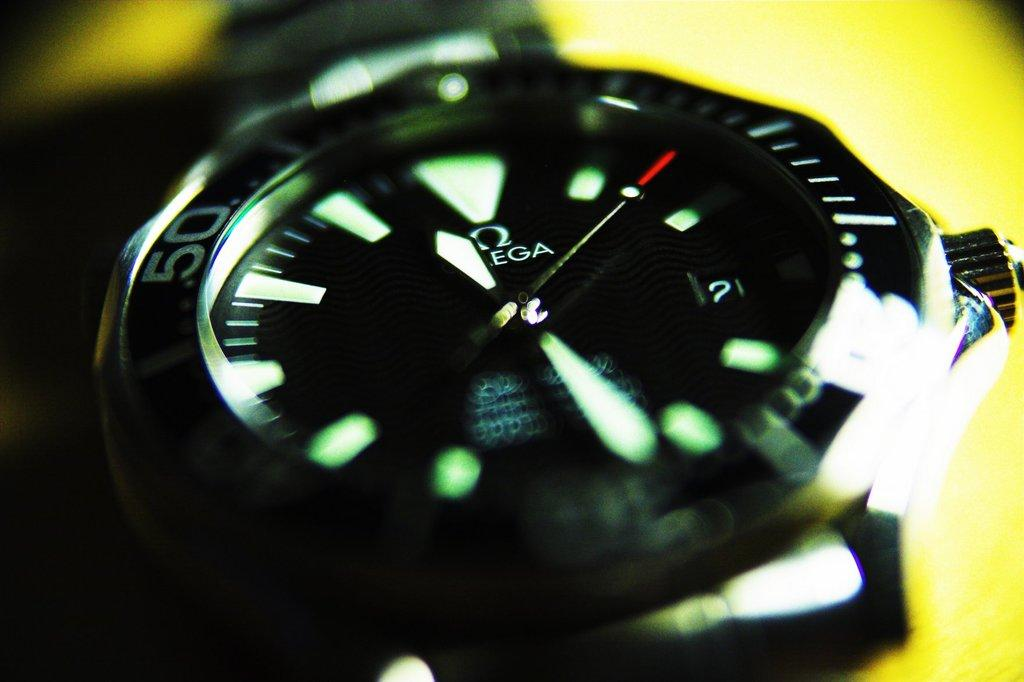<image>
Summarize the visual content of the image. A close up of an Omega watch that is labeled 50 on the side. 